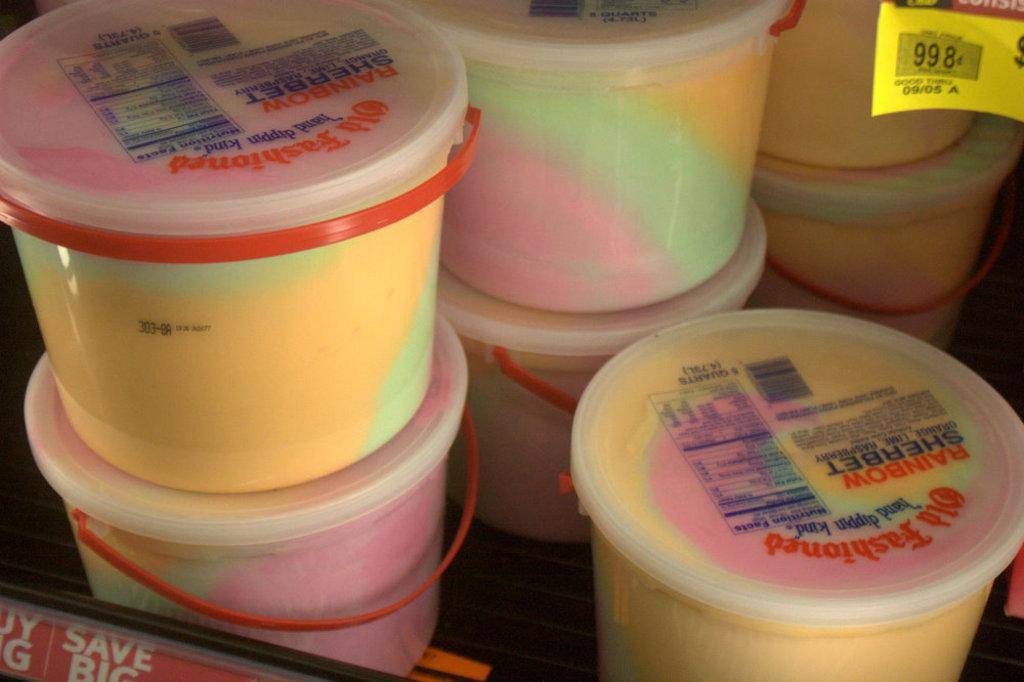<image>
Share a concise interpretation of the image provided. Various tubs of ice cream that are on sale 